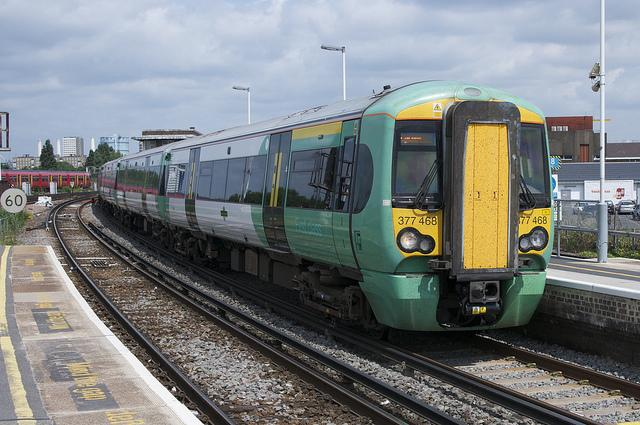What are the black poles on the front train window? wipers 